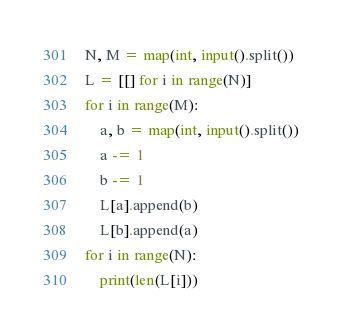<code> <loc_0><loc_0><loc_500><loc_500><_Python_>N, M = map(int, input().split())
L = [[] for i in range(N)]
for i in range(M):
    a, b = map(int, input().split())
    a -= 1
    b -= 1
    L[a].append(b)
    L[b].append(a)
for i in range(N):
    print(len(L[i]))
</code> 